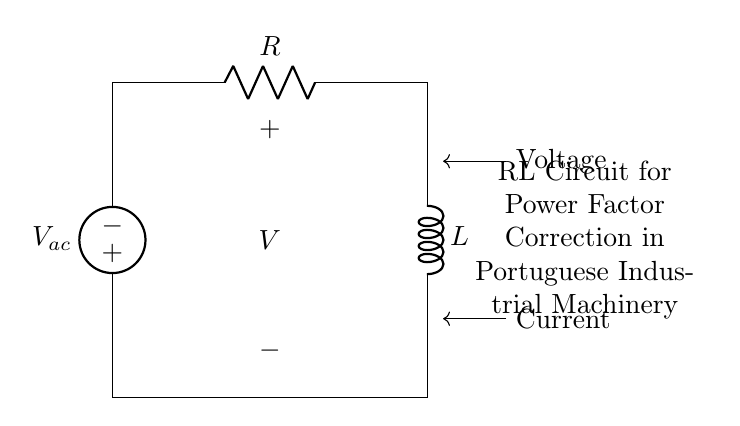What does the circuit contain? The circuit diagram contains a voltage source, a resistor, and an inductor, as indicated by their respective symbols.
Answer: voltage source, resistor, inductor What is the purpose of this circuit? The purpose of this circuit is power factor correction in industrial machinery, which improves the efficiency of power consumption.
Answer: power factor correction What is the voltage across the circuit? The circuit shows a voltage source labeled as V ac. This indicates the applied voltage across the circuit and is represented by the symbol.
Answer: V ac What type of circuit is this? This is an RL circuit, identified by the combination of resistor and inductor components in series, commonly used to deal with inductive loads.
Answer: RL circuit How do the components affect current? The resistor limits current flow due to its resistance, while the inductor can oppose changes in current, affecting the overall current according to the reactance.
Answer: resistor, inductor What happens when the circuit is connected to an AC source? When connected to an AC source, the resistor and inductor create a phase difference between current and voltage, impacting the overall power factor of the system.
Answer: phase difference What will be the net impedance of this circuit? The net impedance of an RL circuit can be calculated as the square root of the sum of the squares of the resistance and inductive reactance.
Answer: Z = sqrt(R^2 + XL^2) 